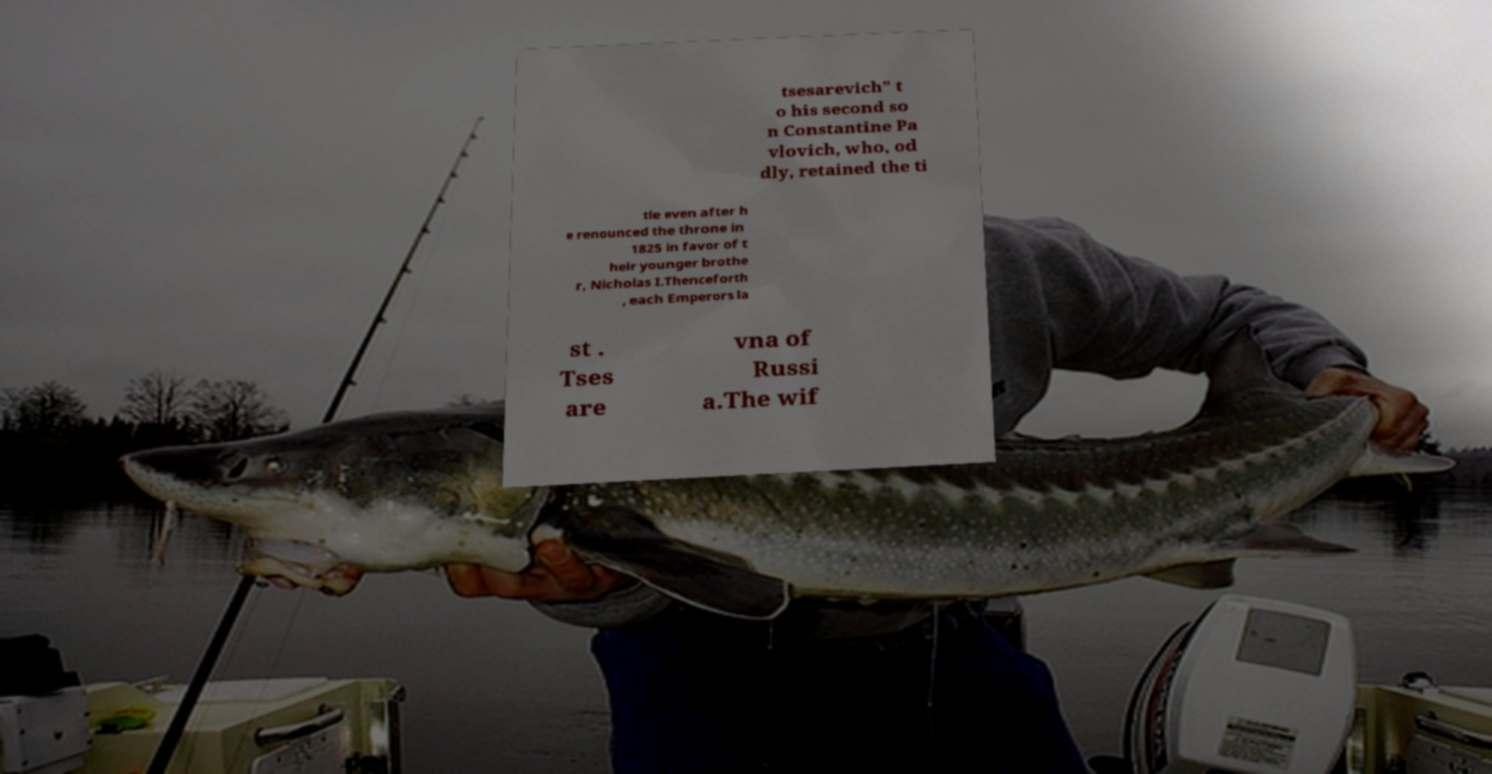Could you assist in decoding the text presented in this image and type it out clearly? tsesarevich" t o his second so n Constantine Pa vlovich, who, od dly, retained the ti tle even after h e renounced the throne in 1825 in favor of t heir younger brothe r, Nicholas I.Thenceforth , each Emperors la st . Tses are vna of Russi a.The wif 